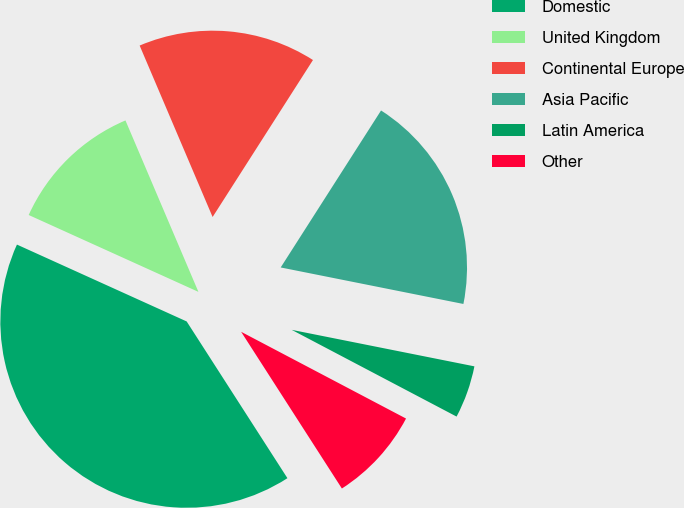Convert chart to OTSL. <chart><loc_0><loc_0><loc_500><loc_500><pie_chart><fcel>Domestic<fcel>United Kingdom<fcel>Continental Europe<fcel>Asia Pacific<fcel>Latin America<fcel>Other<nl><fcel>40.87%<fcel>11.83%<fcel>15.46%<fcel>19.09%<fcel>4.57%<fcel>8.2%<nl></chart> 